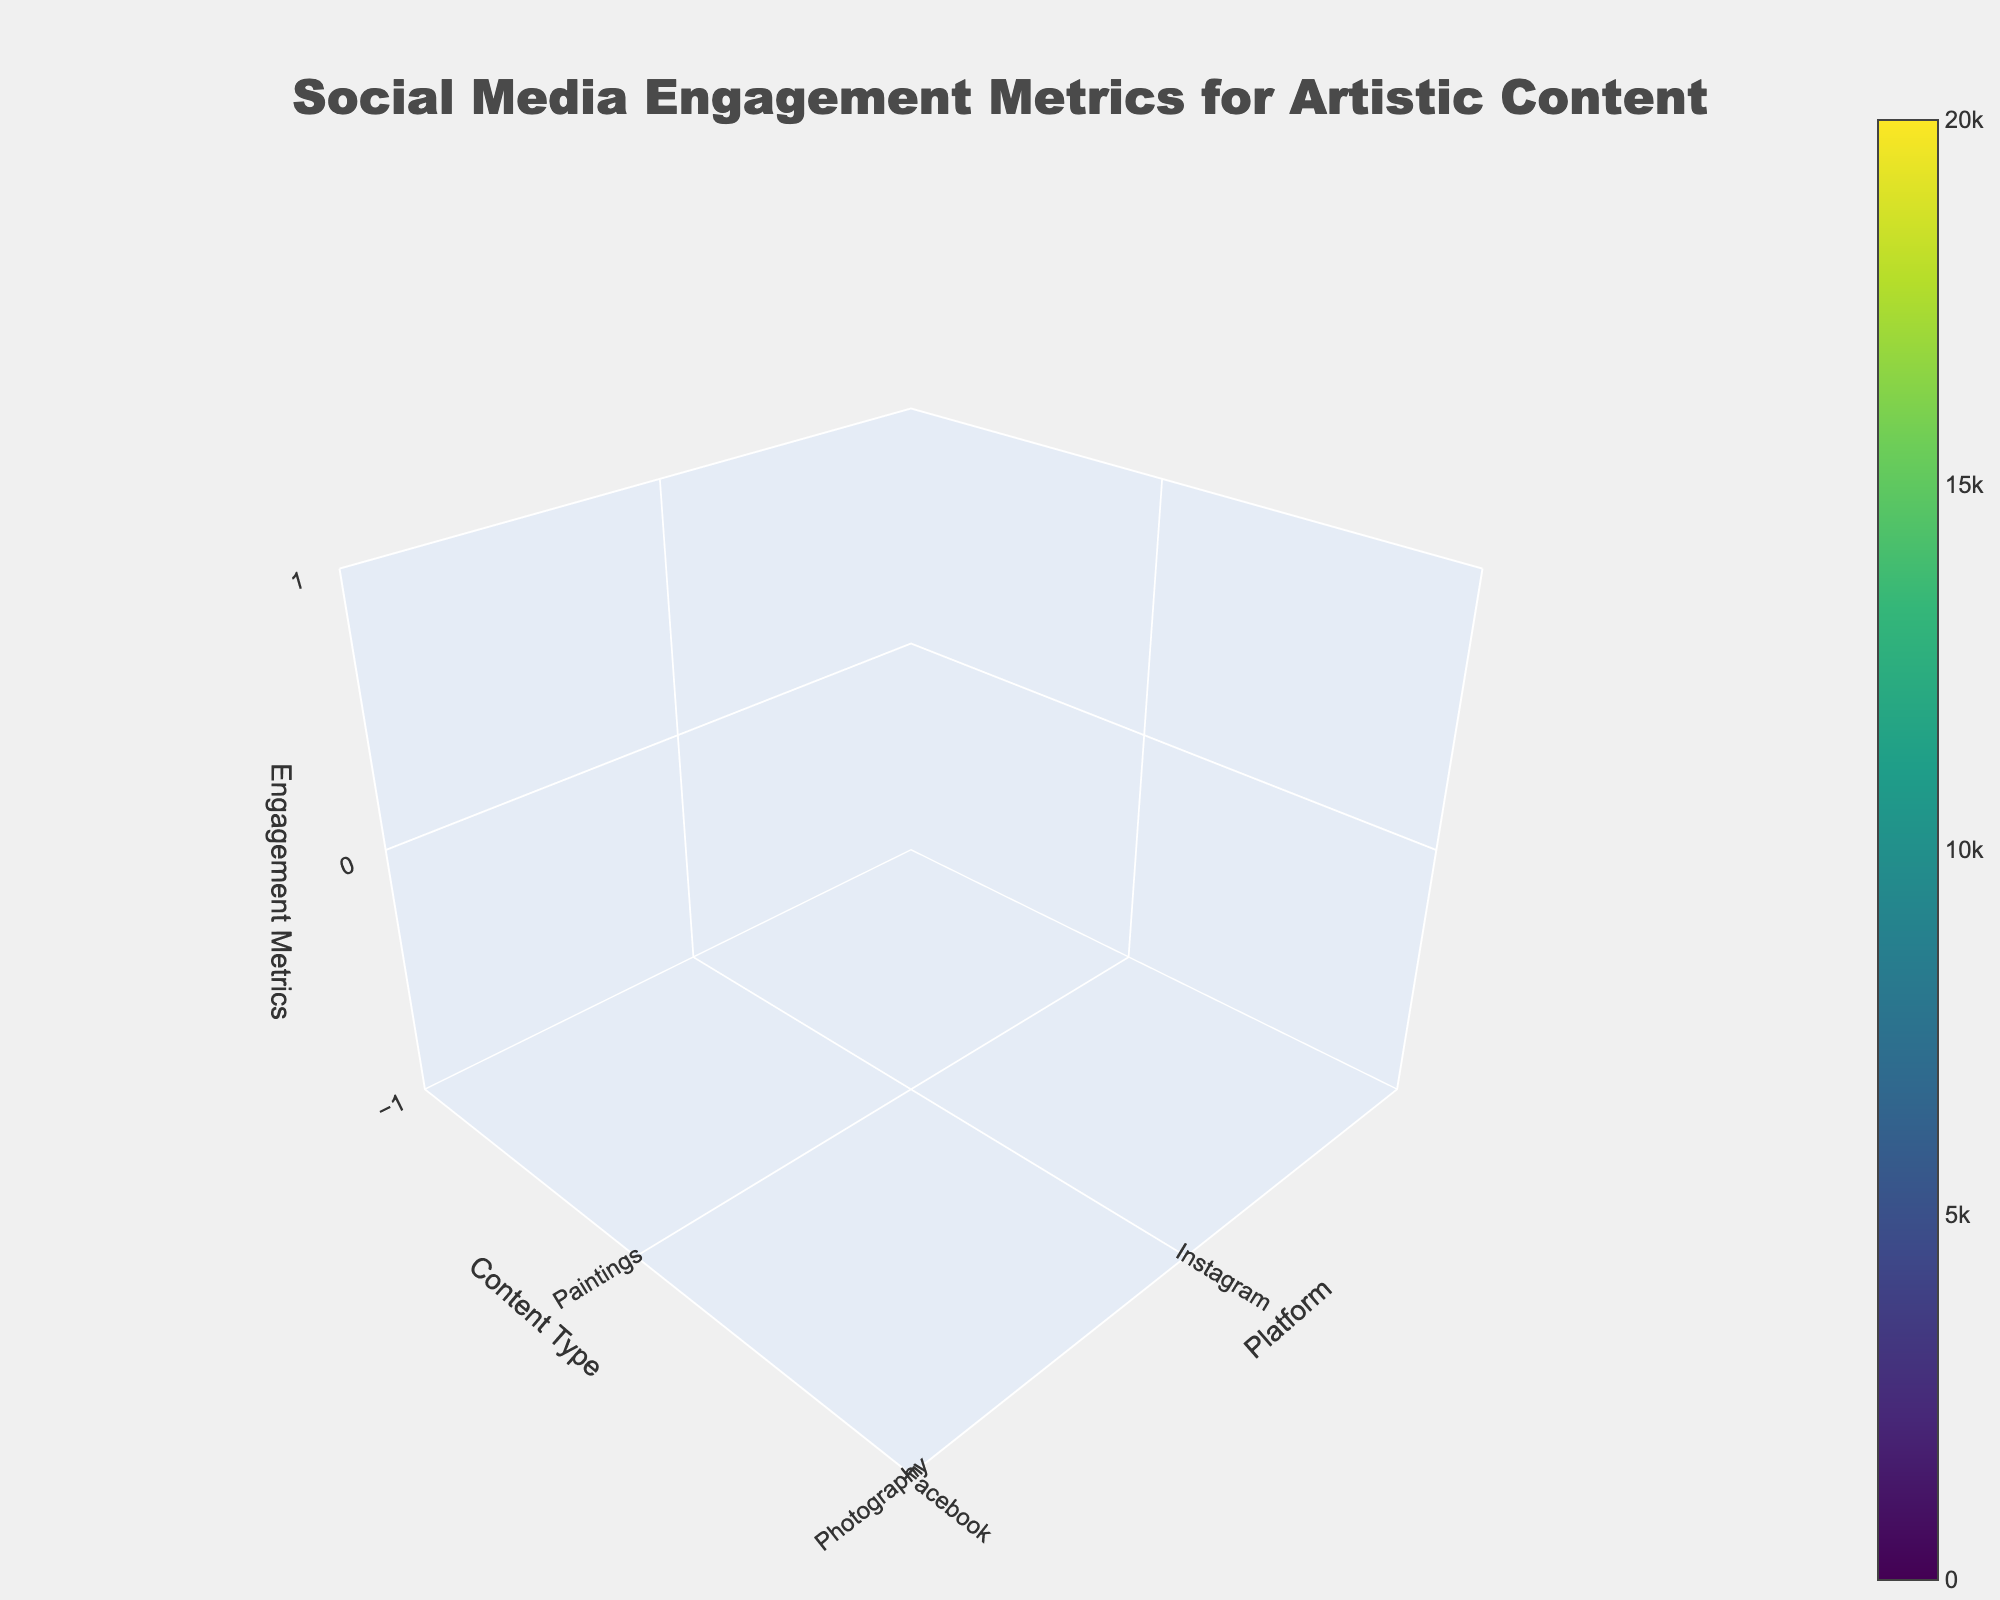What is the title of the 3D volume plot? The title is located at the top of the plot and is usually larger in size than other text elements.
Answer: Social Media Engagement Metrics for Artistic Content Which platform shows the highest overall engagement for Digital Art? By observing the height of the volume elements for Digital Art across all platforms, TikTok has the highest overall engagement metrics (Likes, Comments, Shares) for Digital Art.
Answer: TikTok How do the engagement metrics for Sculptures on Twitter compare to those on Facebook? Compare the height of the volume elements for Sculptures on Twitter and Facebook. Twitter shows generally lower engagement metrics (Likes, Comments, Shares) compared to Facebook.
Answer: Lower on Twitter What is the average number of Likes for Paintings across all platforms? Calculate the mean of Likes for Paintings across Instagram, Facebook, Twitter, and TikTok. (15000+8000+5000+20000)/4 = 12000
Answer: 12000 Which content type shows the most diverse engagement metrics across all platforms? Compare the variation in engagement metrics (the spread of the height of volume) across all platforms for each content type. Paintings exhibit diverse engagement metrics with noticeable differences in values.
Answer: Paintings Between Instagram and TikTok, which platform generates more Comments for Photography? By comparing the height of the volume elements for Comments specifically for Photography on Instagram and TikTok, TikTok is higher.
Answer: TikTok What is the combined total of Shares for all types of content on Facebook? Sum the values of Shares for all content types on Facebook. 4000 (Paintings) + 3500 (Photography) + 2500 (Sculptures) + 3000 (Digital Art) = 13000
Answer: 13000 Which metric shows more consistency across different platforms for all content types: Likes or Comments? By assessing the level of height variation in the volume elements for Likes and Comments across platforms for all content types, Comments appear more consistent with less variation.
Answer: Comments What is the range of Likes for Digital Art across all platforms? The range is found by subtracting the minimum Likes value from the maximum Likes value for Digital Art across all platforms. Max: 15000 (TikTok), Min: 6000 (Facebook). Range = 15000 - 6000 = 9000
Answer: 9000 On which platform does Photography generate more Shares than Likes? Compare the height of volume elements representing Likes and Shares for Photography on each platform. On Twitter, Photography generates more Shares than Likes.
Answer: Twitter 